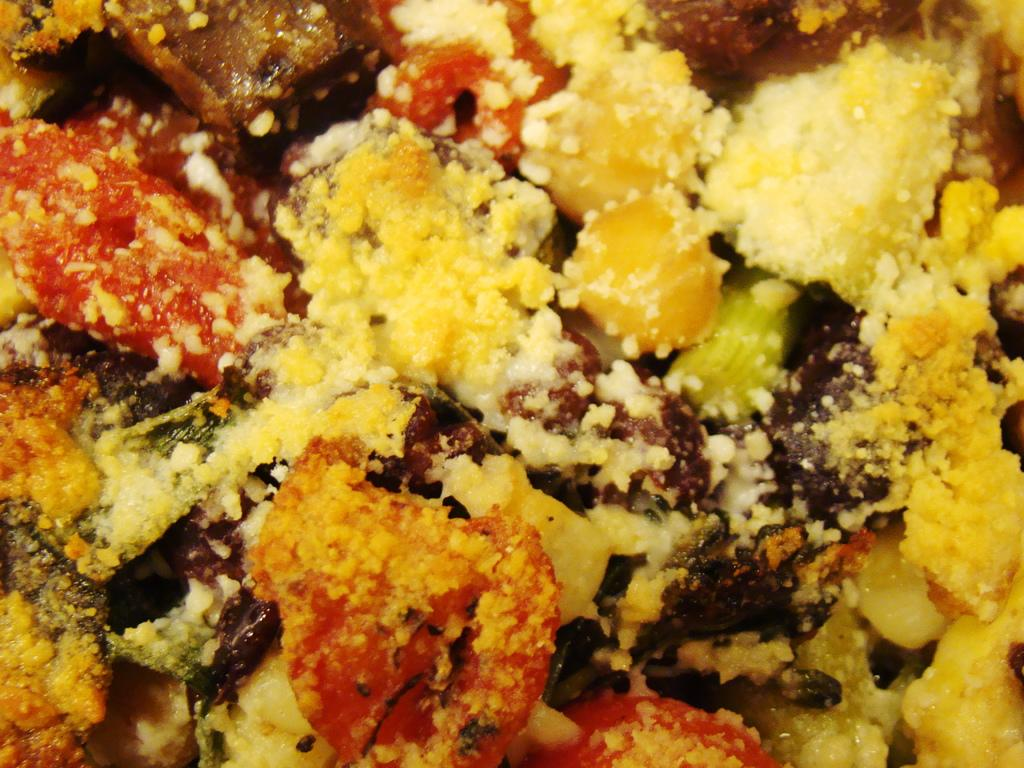What can be seen in the image? There is food in the image. What type of bread is the mother selecting in the image? There is no mother or bread present in the image; it only shows food. 